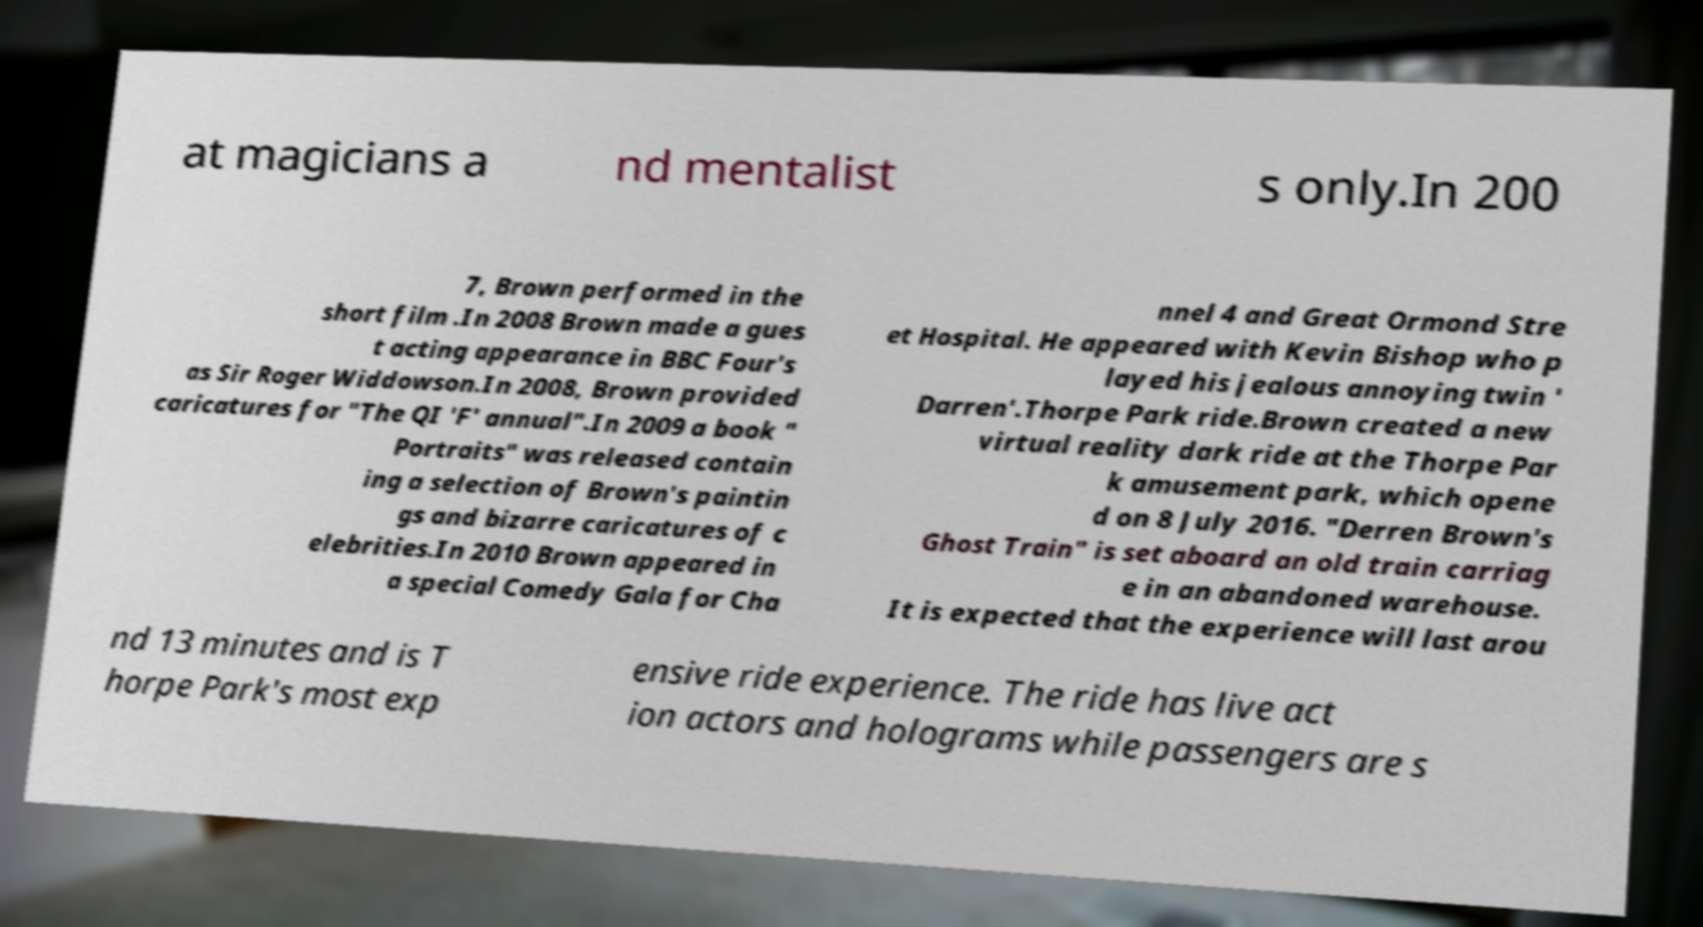Can you read and provide the text displayed in the image?This photo seems to have some interesting text. Can you extract and type it out for me? at magicians a nd mentalist s only.In 200 7, Brown performed in the short film .In 2008 Brown made a gues t acting appearance in BBC Four's as Sir Roger Widdowson.In 2008, Brown provided caricatures for "The QI 'F' annual".In 2009 a book " Portraits" was released contain ing a selection of Brown's paintin gs and bizarre caricatures of c elebrities.In 2010 Brown appeared in a special Comedy Gala for Cha nnel 4 and Great Ormond Stre et Hospital. He appeared with Kevin Bishop who p layed his jealous annoying twin ' Darren'.Thorpe Park ride.Brown created a new virtual reality dark ride at the Thorpe Par k amusement park, which opene d on 8 July 2016. "Derren Brown's Ghost Train" is set aboard an old train carriag e in an abandoned warehouse. It is expected that the experience will last arou nd 13 minutes and is T horpe Park's most exp ensive ride experience. The ride has live act ion actors and holograms while passengers are s 